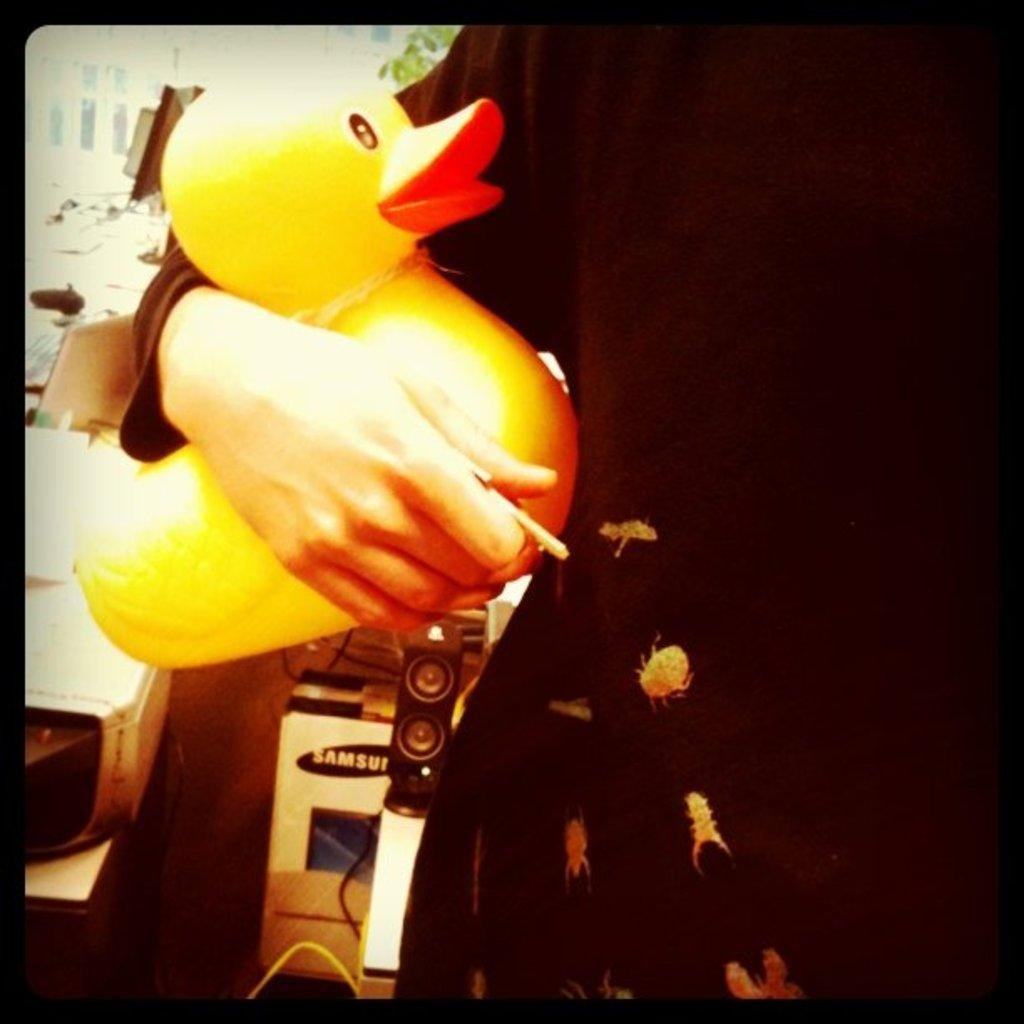What is the main subject of the picture? There is a person in the picture. What is the person holding in the picture? The person is holding a duck toy. What is the person wearing in the picture? The person is wearing a black dress. How does the person provide support to the heat in the image? There is no mention of heat or support in the image, as it features a person holding a duck toy while wearing a black dress. 